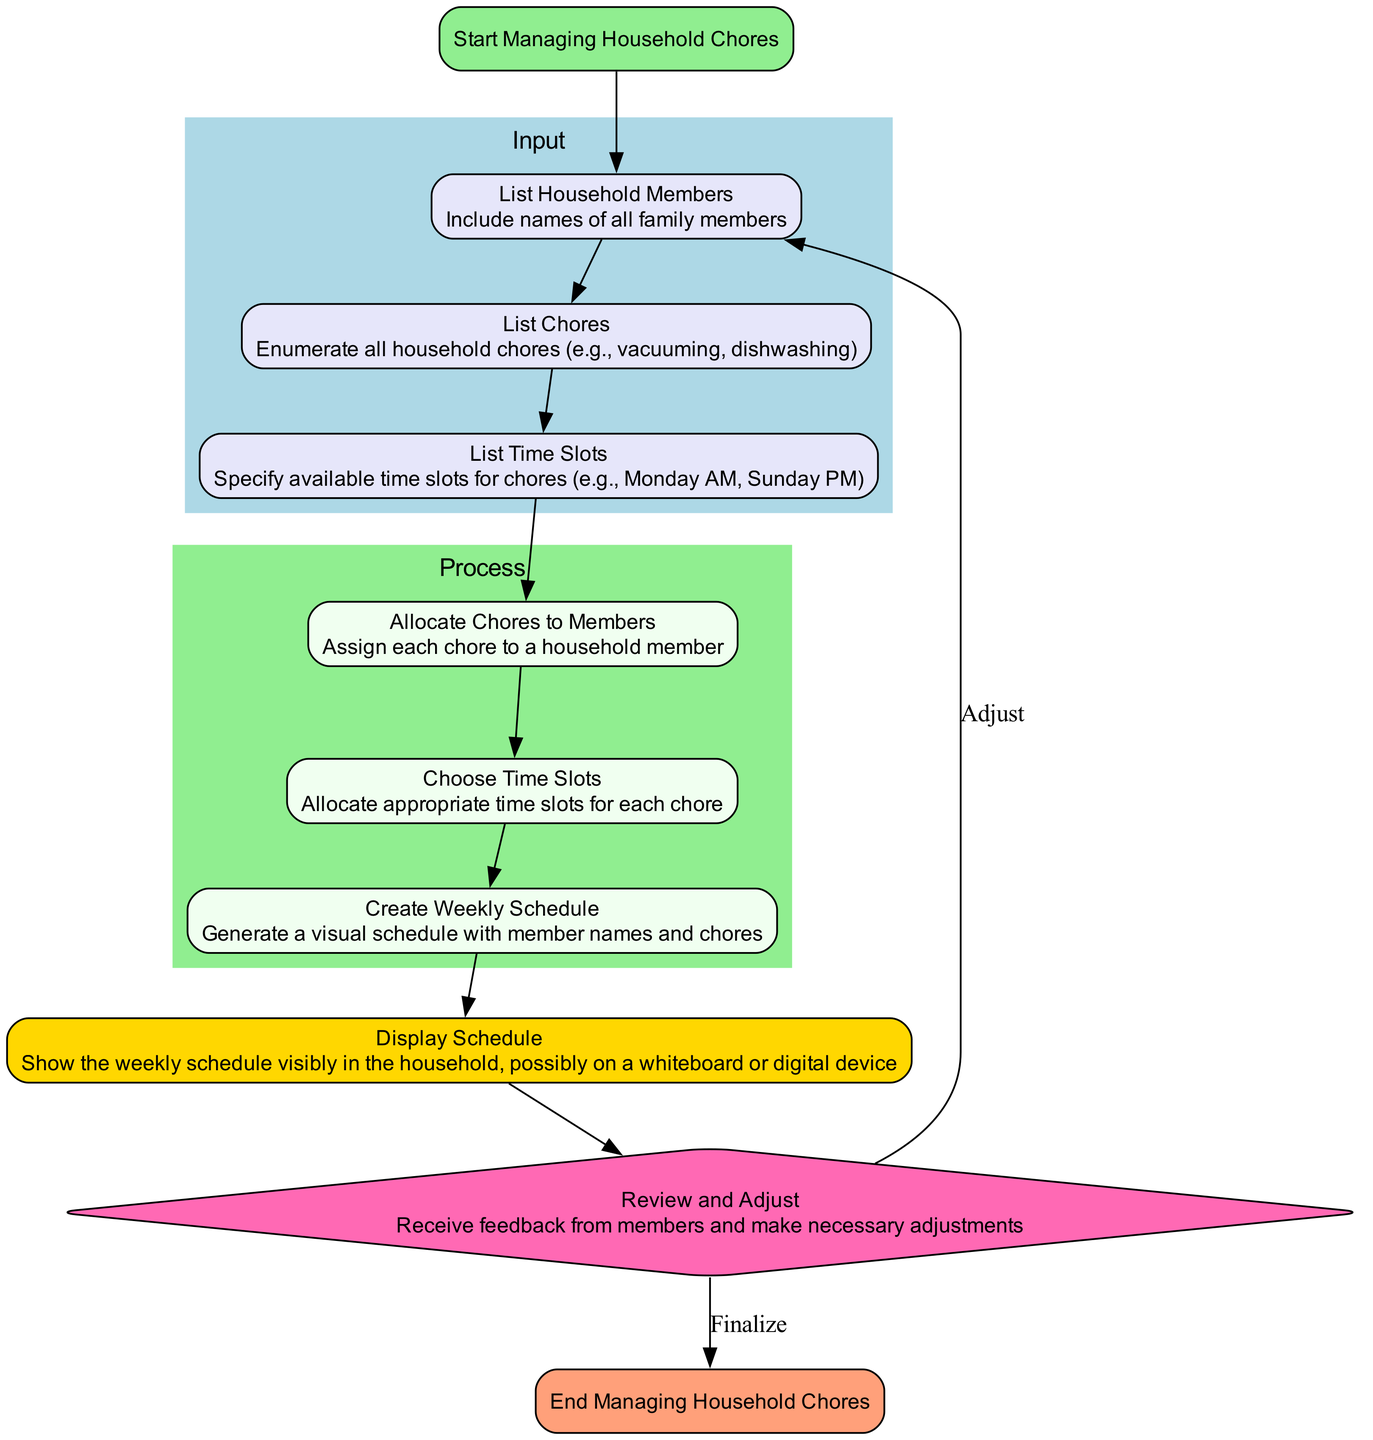What is the first step in managing household chores? The flowchart begins with the node labeled "Start," which indicates "Start Managing Household Chores." This is the first action taken in the process.
Answer: Start Managing Household Chores How many input elements are listed in the diagram? There are three input elements: "List Household Members," "List Chores," and "List Time Slots." Counting these provides the total number of input elements.
Answer: 3 What is the last process to be completed? The last process described in the diagram is "Create Weekly Schedule." This is indicated as the final action in the process sequence before moving to the output.
Answer: Create Weekly Schedule Which node represents the feedback loop in the flowchart? The feedback loop is represented by the node labeled "Review and Adjust." This node is distinctly shaped as a diamond, indicating its role in the process as a decision point for adjustments.
Answer: Review and Adjust What step follows "Choose Time Slots" in the process sequence? After "Choose Time Slots," the flowchart indicates "Create Weekly Schedule" as the next step. This can be determined by following the edges linking the nodes in sequence.
Answer: Create Weekly Schedule After displaying the schedule, what option is available? Following the display of the schedule, the diagram offers two options: "Adjust" (which leads back to "List Household Members") or "Finalize" (which leads to "End"). This can be inferred from the outgoing edges from the "Display Schedule" node.
Answer: Adjust, Finalize 